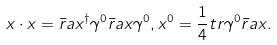<formula> <loc_0><loc_0><loc_500><loc_500>x \cdot x = \bar { r } a { x } ^ { \dag } \gamma ^ { 0 } \bar { r } a { x } \gamma ^ { 0 } , x ^ { 0 } = \frac { 1 } { 4 } t r \gamma ^ { 0 } \bar { r } a { x } .</formula> 